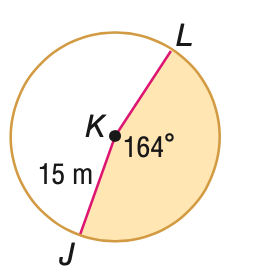Answer the mathemtical geometry problem and directly provide the correct option letter.
Question: Find the area of the shaded sector. Round to the nearest tenth, if necessary.
Choices: A: 42.9 B: 51.3 C: 322.0 D: 706.9 C 